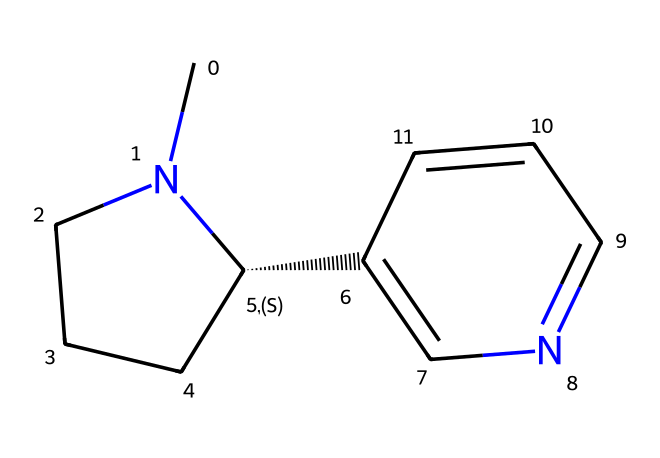What is the molecular formula of nicotine? To determine the molecular formula, we count the types and numbers of atoms represented in the SMILES notation. The breakdown shows there are 10 carbon atoms (C), 14 hydrogen atoms (H), and 2 nitrogen atoms (N), leading to the formula C10H14N2.
Answer: C10H14N2 How many nitrogen atoms are present in nicotine? By analyzing the SMILES structure, we can see that there are 2 nitrogen atoms indicated in the configuration.
Answer: 2 What type of organic compound is nicotine classified as? Nicotine is classified as an alkaloid due to the presence of nitrogen in a heterocyclic structure, which is common in this type of organic compounds.
Answer: alkaloid How many rings are present in the molecular structure of nicotine? Looking at the SMILES representation, we can identify there are two distinct cyclic structures in the molecule, indicating two rings.
Answer: 2 What characteristic feature of nicotine contributes to its addictive properties? The presence of nitrogen atoms and the specific structure allows for interaction with nicotinic acetylcholine receptors in the brain, contributing to its addictive nature.
Answer: nitrogen What is the role of the carbon backbone in nicotine's structure? The carbon backbone provides the framework for the molecule, allowing for the connectivity that enables the interaction with biological systems.
Answer: framework 